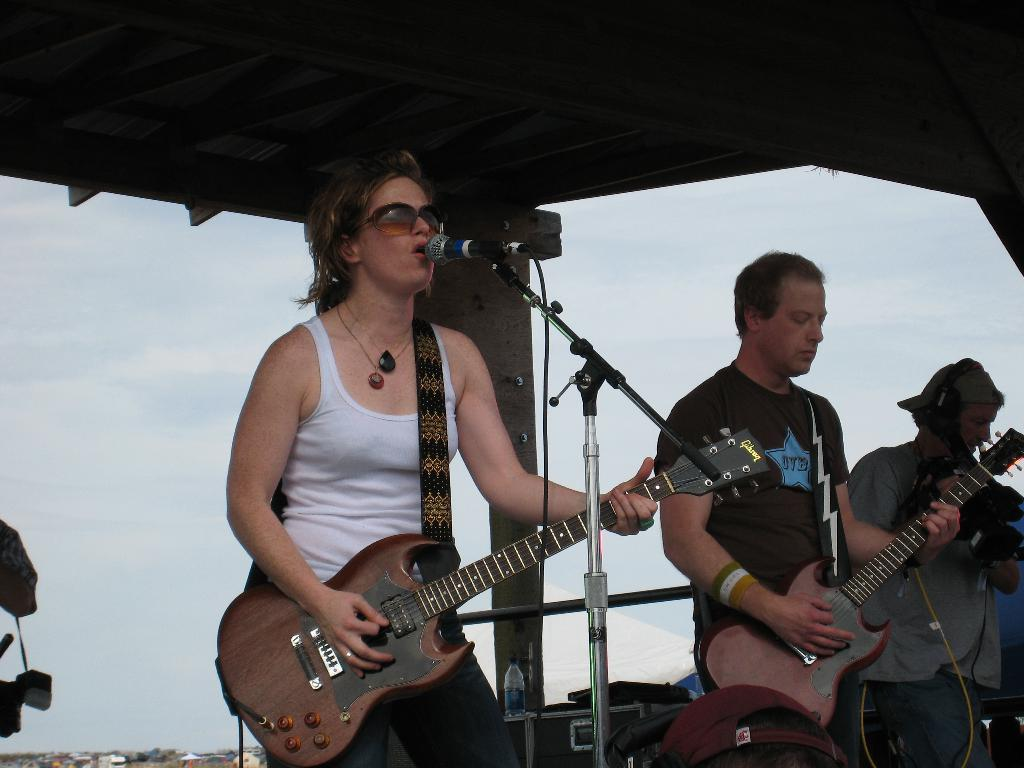How many people are in the image? There are two persons in the image. What are the persons doing in the image? Both persons are playing guitars, and one person is singing on a microphone. Can you describe the person who is singing? The person singing has spectacles. What is the gender of the person playing the guitar? The facts provided mention that there is a man in the image, so one of the persons playing the guitar is a man. What can be seen in the background of the image? The sky is visible in the background of the image. What type of island can be seen in the background of the image? There is no island present in the image; the background features the sky. What color is the dirt on the ground in the image? There is no dirt present in the image; the ground is not visible. 